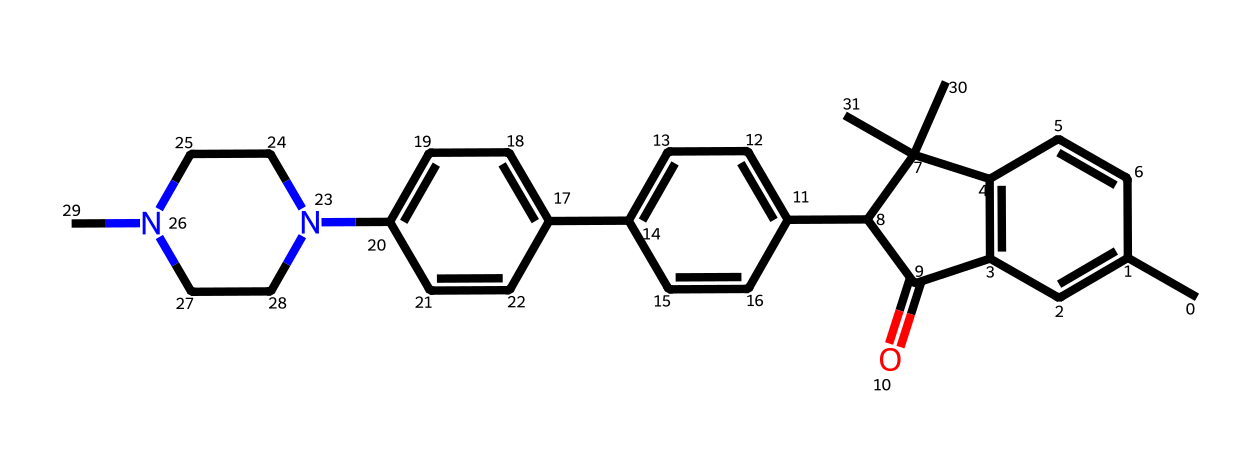What is the molecular formula of loratadine? To find the molecular formula, we need to identify the number of each type of atom in the chemical structure represented by the SMILES notation. By analyzing the SMILES, we can count the atoms: 22 carbon (C) atoms, 23 hydrogen (H) atoms, 1 nitrogen (N) atom, and 2 oxygen (O) atoms. Thus, the molecular formula is C22H23N2O2.
Answer: C22H23N2O2 How many nitrogen atoms are present in this compound? The SMILES representation indicates there is one nitrogen (N) atom. By examining the structure and counting each nitrogen symbol, we identify that there is only one present in the compound.
Answer: 1 What functional groups can be identified in loratadine? By examining the structure indicated in the SMILES, we can identify several functional groups: there is an amine group (due to the nitrogen atom), and carbonyl groups (due to the carbon atoms adjacent to oxygen). This contributes to its classification.
Answer: amine, carbonyl What is the significance of increased pollen levels for loratadine use? Increased pollen levels lead to heightened allergic reactions, making loratadine beneficial due to its antihistaminic properties. The presence of specific functional groups in loratadine allows it to block histamine receptors, reducing allergic symptoms.
Answer: antihistamine What is the structural feature that allows loratadine to act as an antihistamine? The existence of a tertiary amine in the structure is crucial as it is responsible for its ability to bind effectively to histamine receptors, blocking their activity. This leads to relief from allergy symptoms.
Answer: tertiary amine How many rings are present in the structure of loratadine? In the visual representation of the chemical structure from the SMILES, we can see there are four fused rings present in the compound. By counting these distinct cyclic structures, we confirm the number.
Answer: 4 